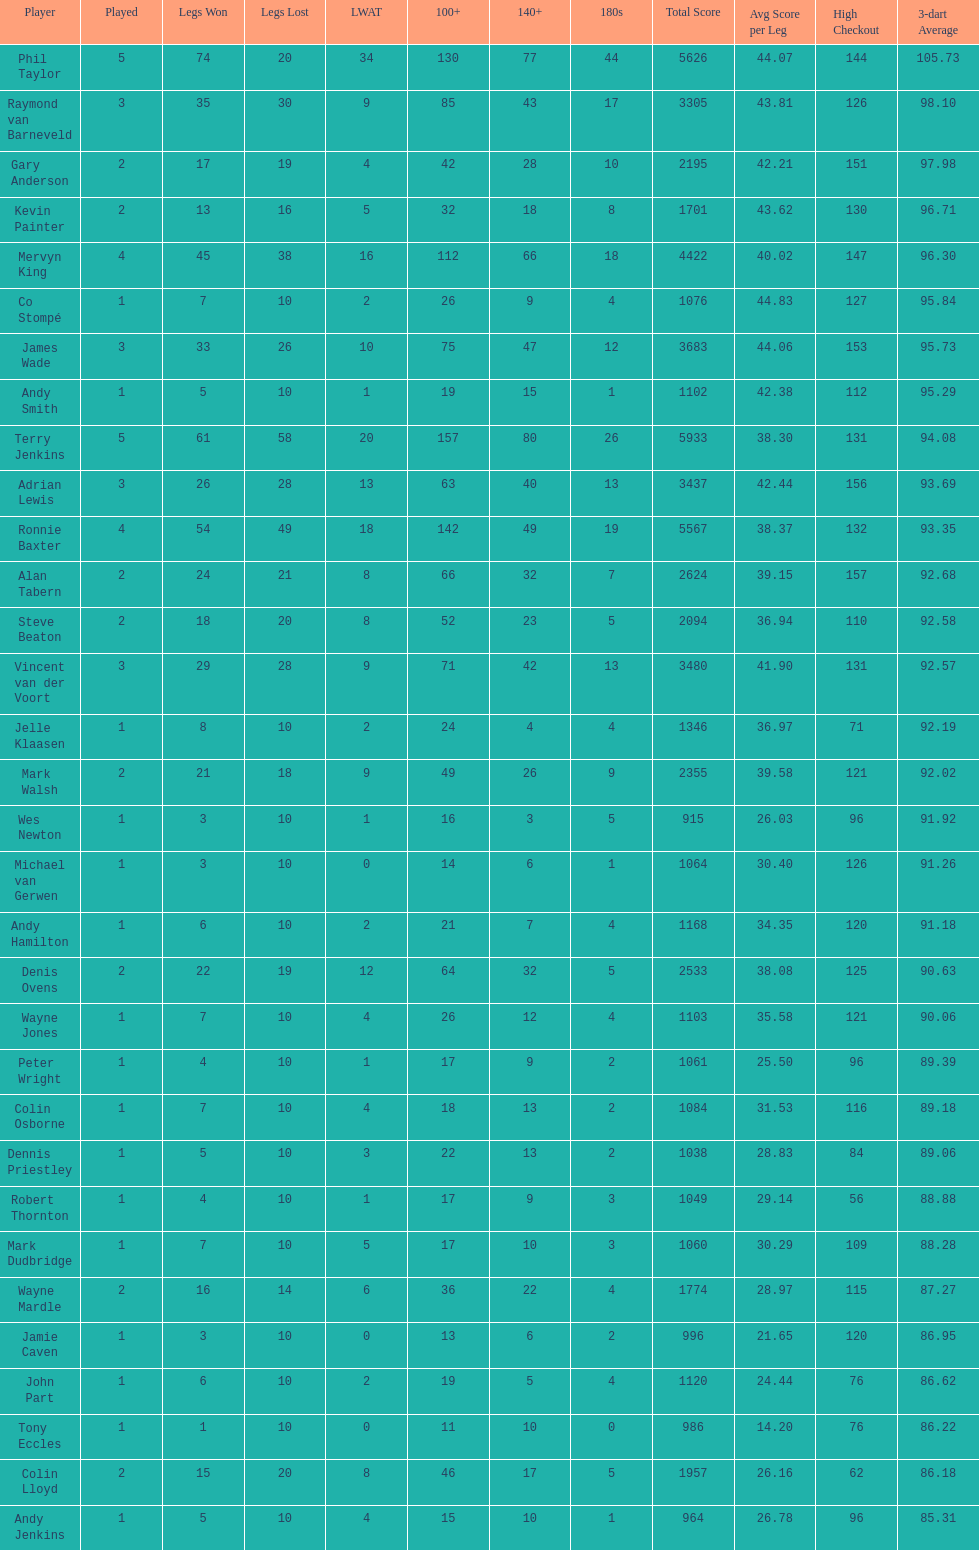What is the total amount of players who played more than 3 games? 4. 